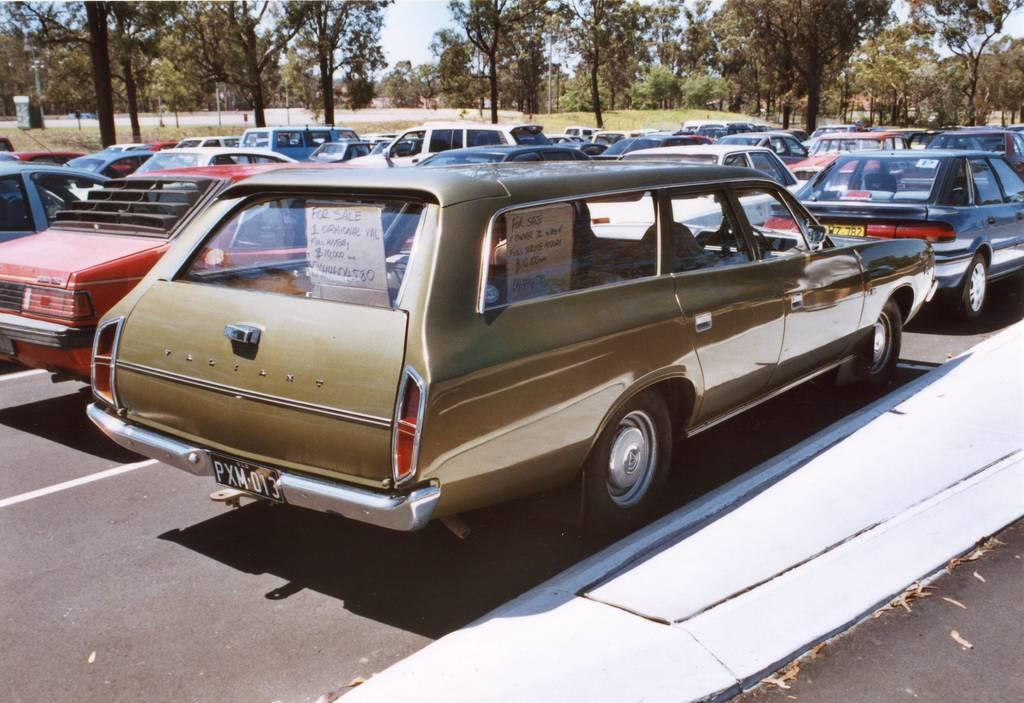What can be seen on the road in the image? There are vehicles on the road in the image. What type of natural elements are visible in the background? There are trees in the background of the image. What other objects can be seen in the background? There are poles and boards in the background of the image. What is visible at the top of the image? The sky is visible at the top of the image. What type of start can be seen in the image? There is no start visible in the image; it features vehicles on the road, trees, poles, boards, and the sky. 